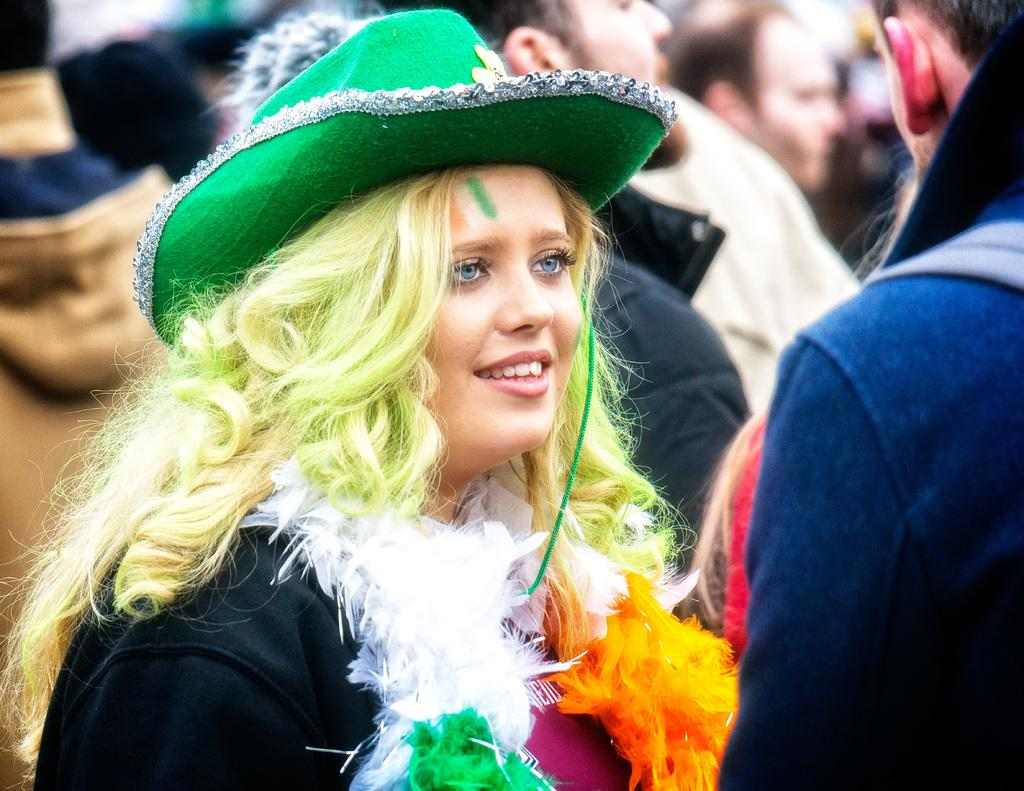Who is the main subject in the image? There is a woman in the image. What is the woman wearing? The woman is wearing a costume. What can be seen on the woman's head? The woman has a green hat. What is unique about the woman's hair? The woman has colored hair. Are there any other people in the image? Yes, there are people standing around the woman in the image. What is the tax rate for the cabbage in the image? There is no mention of tax or cabbage in the image; it features a woman wearing a costume with a green hat and colored hair, surrounded by other people. 